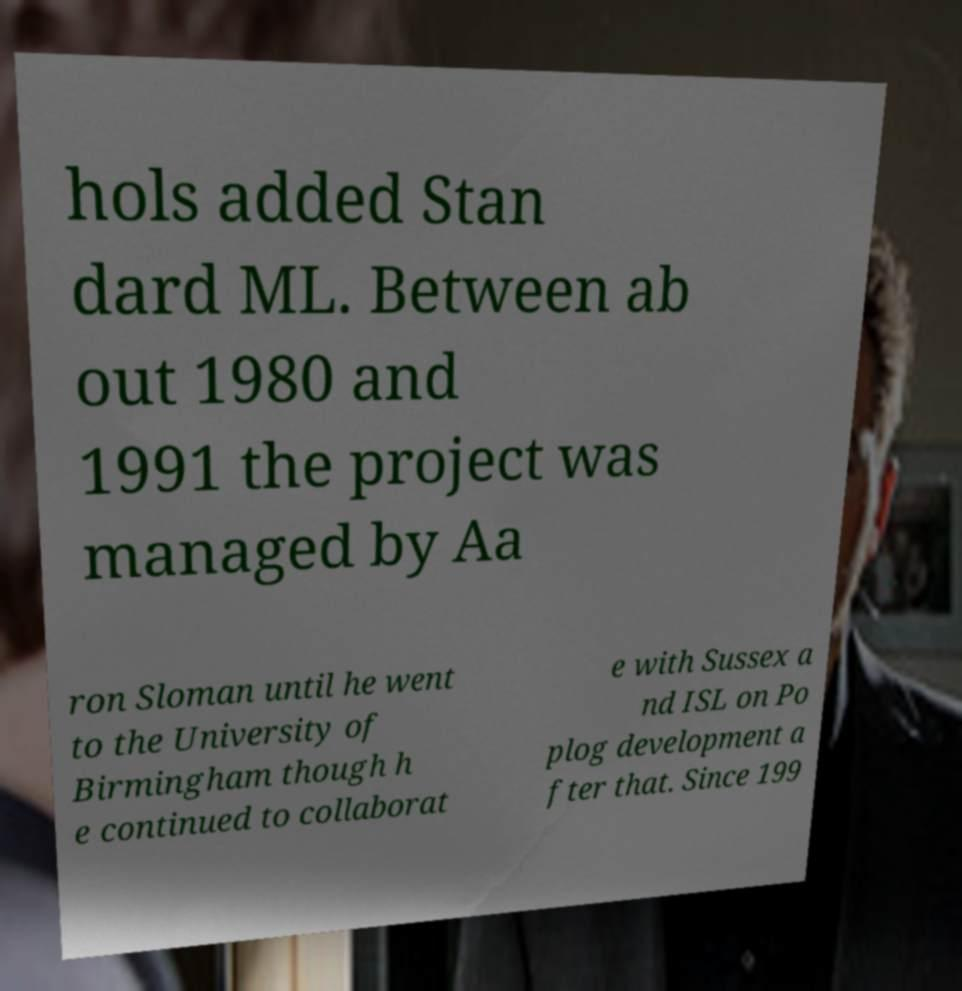Please identify and transcribe the text found in this image. hols added Stan dard ML. Between ab out 1980 and 1991 the project was managed by Aa ron Sloman until he went to the University of Birmingham though h e continued to collaborat e with Sussex a nd ISL on Po plog development a fter that. Since 199 